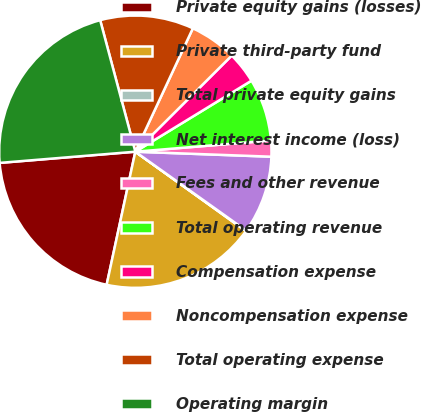<chart> <loc_0><loc_0><loc_500><loc_500><pie_chart><fcel>Private equity gains (losses)<fcel>Private third-party fund<fcel>Total private equity gains<fcel>Net interest income (loss)<fcel>Fees and other revenue<fcel>Total operating revenue<fcel>Compensation expense<fcel>Noncompensation expense<fcel>Total operating expense<fcel>Operating margin<nl><fcel>20.31%<fcel>18.47%<fcel>0.06%<fcel>9.26%<fcel>1.9%<fcel>7.42%<fcel>3.74%<fcel>5.58%<fcel>11.1%<fcel>22.15%<nl></chart> 